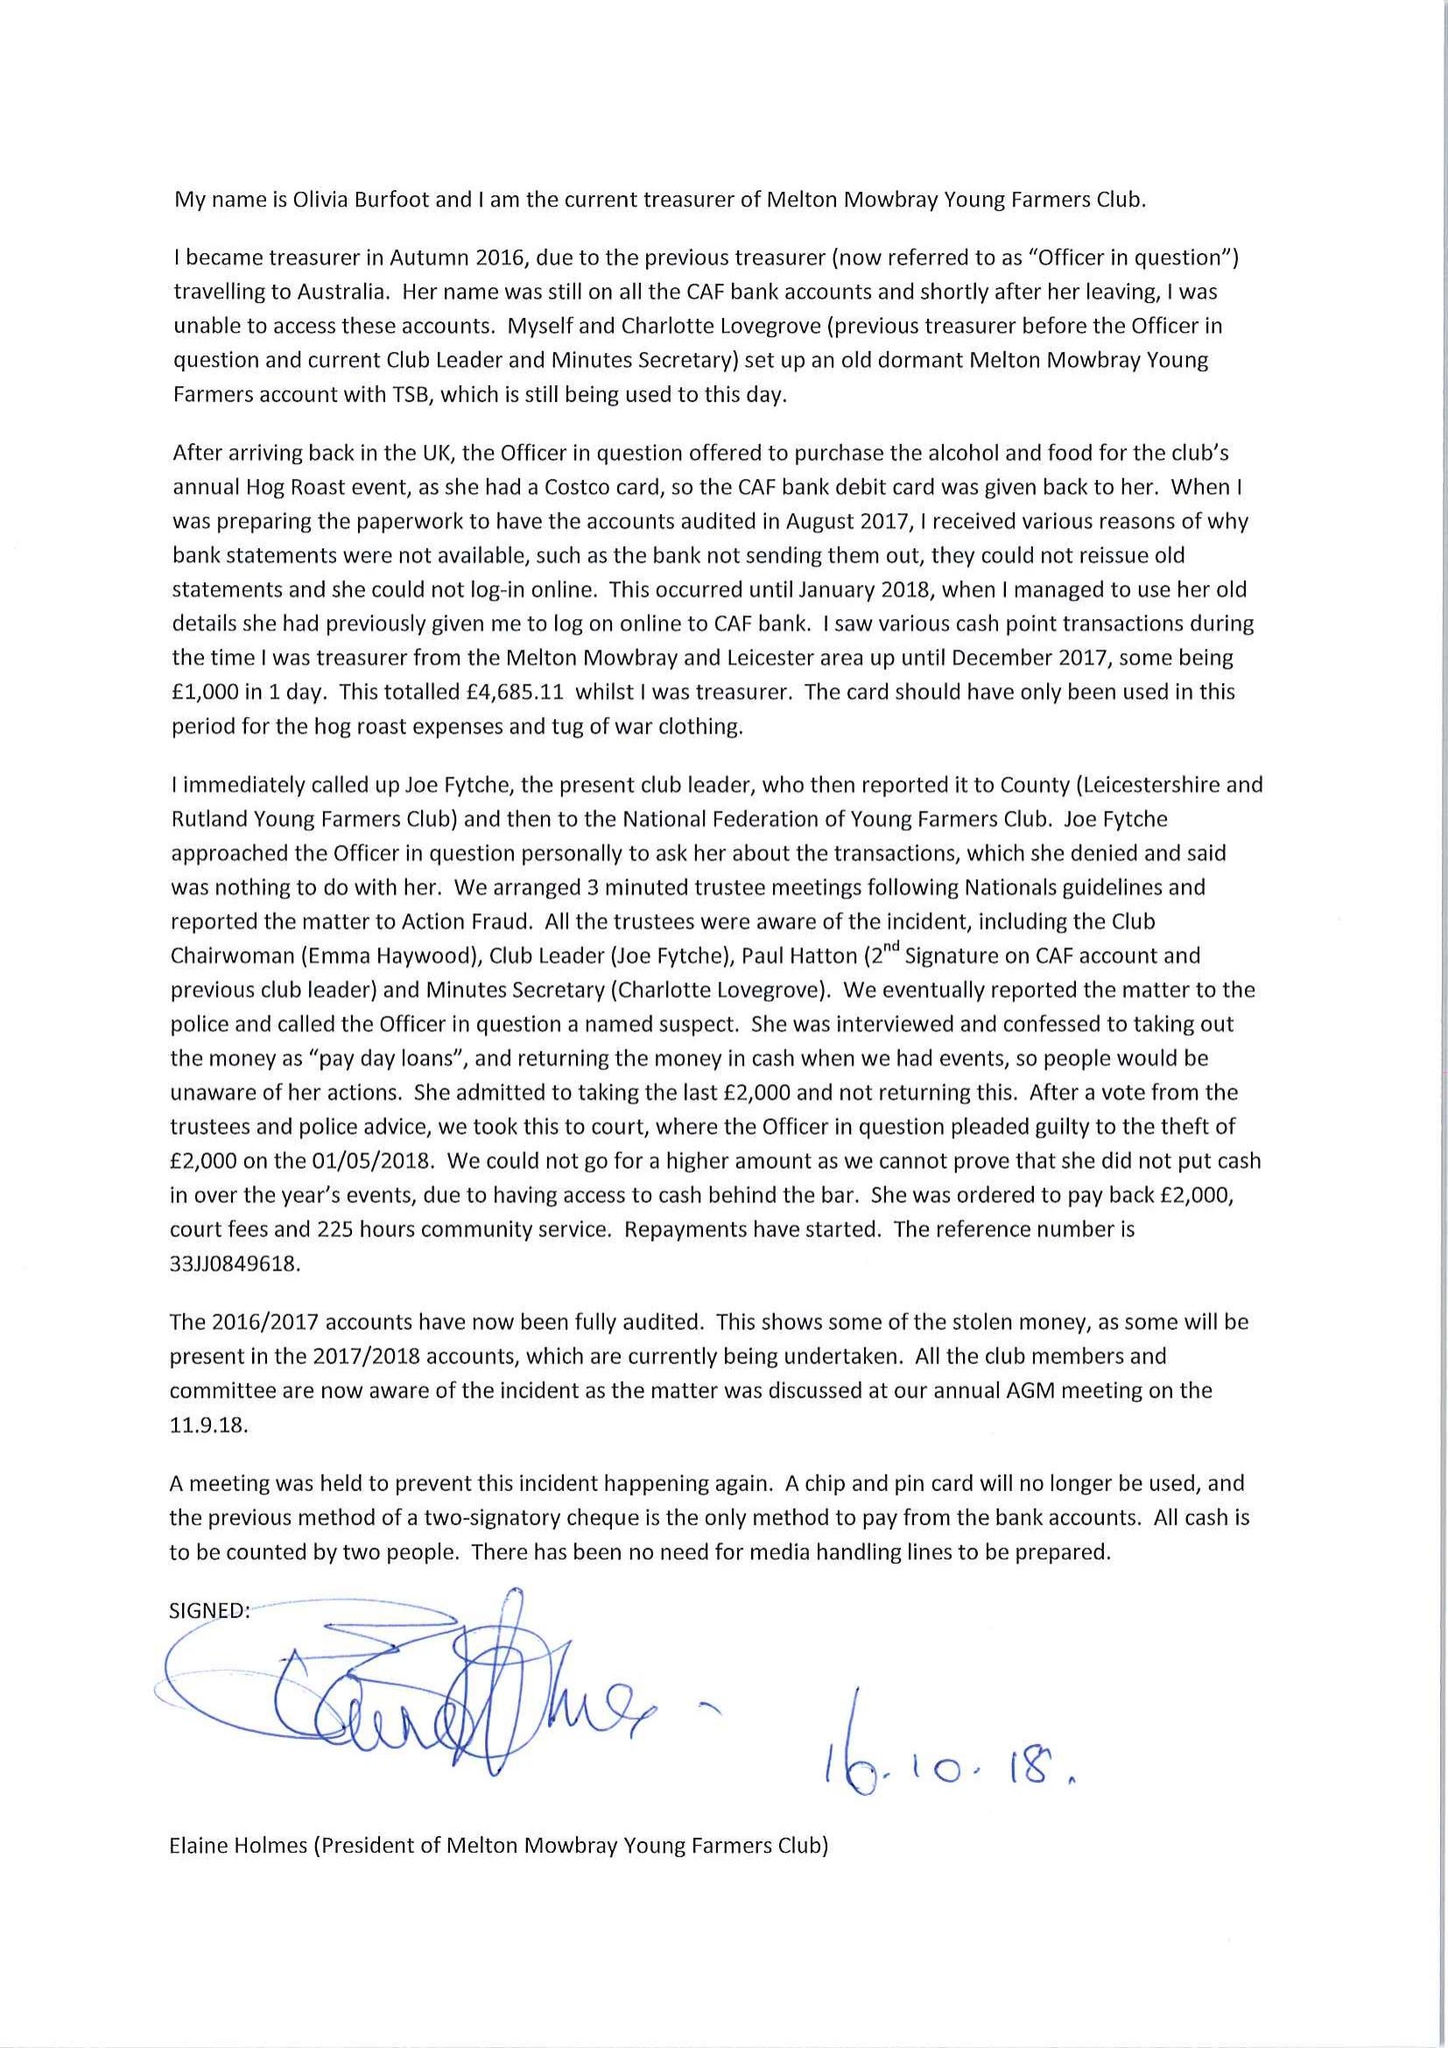What is the value for the charity_name?
Answer the question using a single word or phrase. Melton Mowbray Young Farmers' Club 